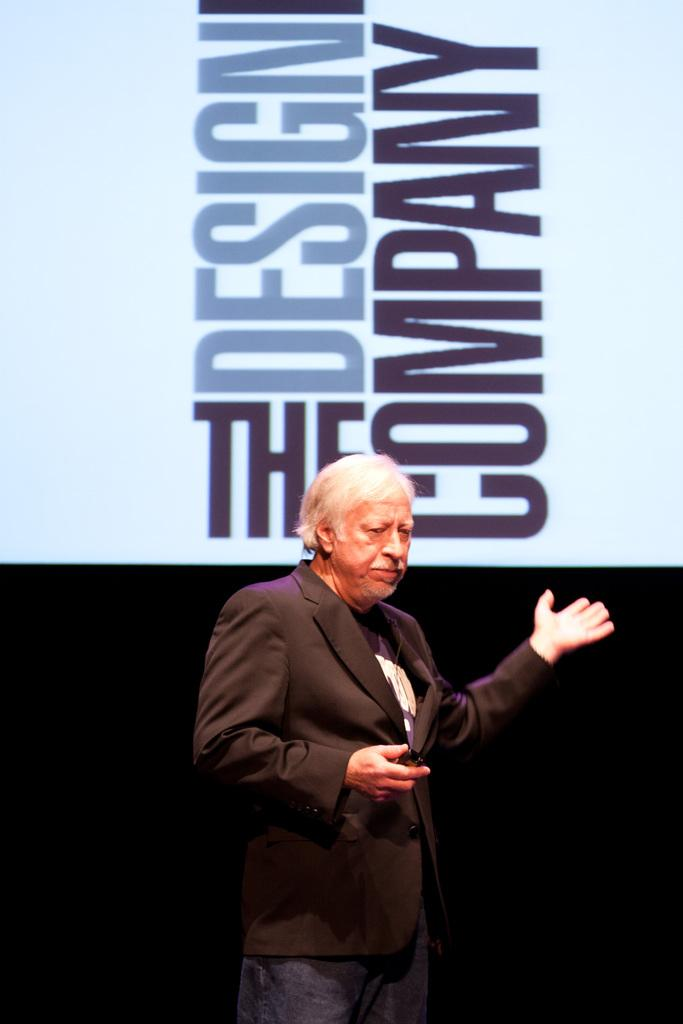Provide a one-sentence caption for the provided image. A white haired man stands in front of a large sign that says "The Design Company". 